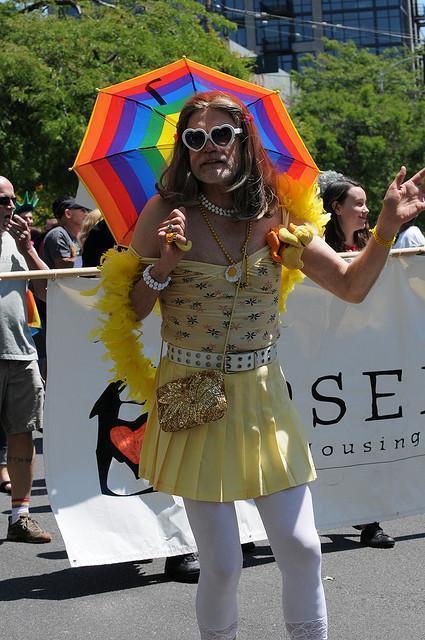What does the man use the umbrella for?
Pick the right solution, then justify: 'Answer: answer
Rationale: rationale.'
Options: Hail, rain, decoration, shade. Answer: shade.
Rationale: The sky is very sunny and is probably trying to stay cool. 